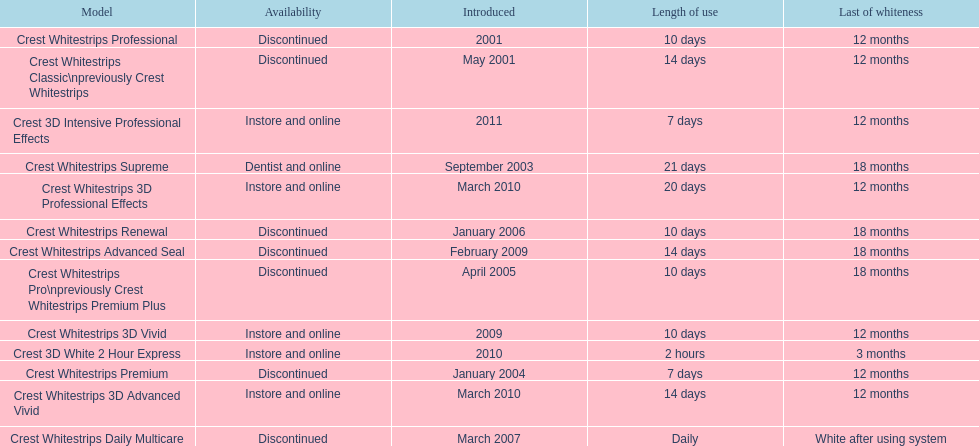Which discontinued product was introduced the same year as crest whitestrips 3d vivid? Crest Whitestrips Advanced Seal. 